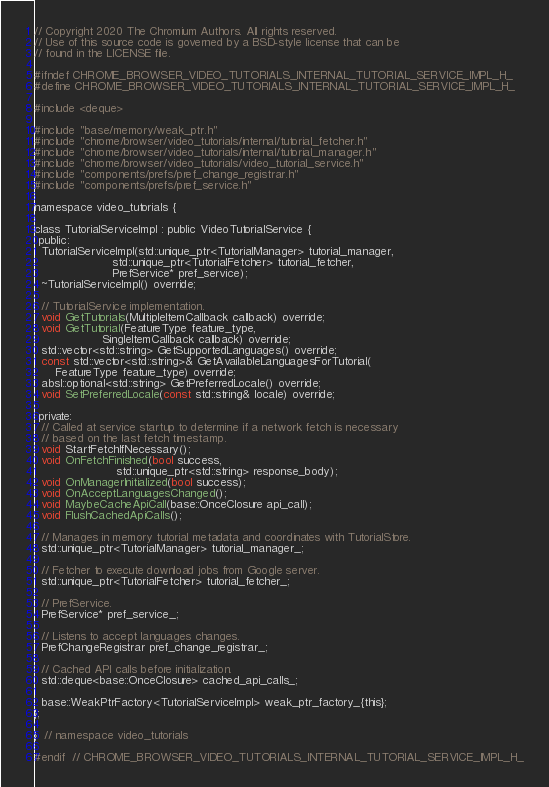Convert code to text. <code><loc_0><loc_0><loc_500><loc_500><_C_>// Copyright 2020 The Chromium Authors. All rights reserved.
// Use of this source code is governed by a BSD-style license that can be
// found in the LICENSE file.

#ifndef CHROME_BROWSER_VIDEO_TUTORIALS_INTERNAL_TUTORIAL_SERVICE_IMPL_H_
#define CHROME_BROWSER_VIDEO_TUTORIALS_INTERNAL_TUTORIAL_SERVICE_IMPL_H_

#include <deque>

#include "base/memory/weak_ptr.h"
#include "chrome/browser/video_tutorials/internal/tutorial_fetcher.h"
#include "chrome/browser/video_tutorials/internal/tutorial_manager.h"
#include "chrome/browser/video_tutorials/video_tutorial_service.h"
#include "components/prefs/pref_change_registrar.h"
#include "components/prefs/pref_service.h"

namespace video_tutorials {

class TutorialServiceImpl : public VideoTutorialService {
 public:
  TutorialServiceImpl(std::unique_ptr<TutorialManager> tutorial_manager,
                      std::unique_ptr<TutorialFetcher> tutorial_fetcher,
                      PrefService* pref_service);
  ~TutorialServiceImpl() override;

  // TutorialService implementation.
  void GetTutorials(MultipleItemCallback callback) override;
  void GetTutorial(FeatureType feature_type,
                   SingleItemCallback callback) override;
  std::vector<std::string> GetSupportedLanguages() override;
  const std::vector<std::string>& GetAvailableLanguagesForTutorial(
      FeatureType feature_type) override;
  absl::optional<std::string> GetPreferredLocale() override;
  void SetPreferredLocale(const std::string& locale) override;

 private:
  // Called at service startup to determine if a network fetch is necessary
  // based on the last fetch timestamp.
  void StartFetchIfNecessary();
  void OnFetchFinished(bool success,
                       std::unique_ptr<std::string> response_body);
  void OnManagerInitialized(bool success);
  void OnAcceptLanguagesChanged();
  void MaybeCacheApiCall(base::OnceClosure api_call);
  void FlushCachedApiCalls();

  // Manages in memory tutorial metadata and coordinates with TutorialStore.
  std::unique_ptr<TutorialManager> tutorial_manager_;

  // Fetcher to execute download jobs from Google server.
  std::unique_ptr<TutorialFetcher> tutorial_fetcher_;

  // PrefService.
  PrefService* pref_service_;

  // Listens to accept languages changes.
  PrefChangeRegistrar pref_change_registrar_;

  // Cached API calls before initialization.
  std::deque<base::OnceClosure> cached_api_calls_;

  base::WeakPtrFactory<TutorialServiceImpl> weak_ptr_factory_{this};
};

}  // namespace video_tutorials

#endif  // CHROME_BROWSER_VIDEO_TUTORIALS_INTERNAL_TUTORIAL_SERVICE_IMPL_H_
</code> 